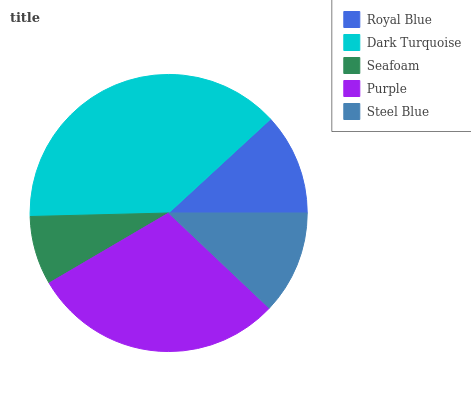Is Seafoam the minimum?
Answer yes or no. Yes. Is Dark Turquoise the maximum?
Answer yes or no. Yes. Is Dark Turquoise the minimum?
Answer yes or no. No. Is Seafoam the maximum?
Answer yes or no. No. Is Dark Turquoise greater than Seafoam?
Answer yes or no. Yes. Is Seafoam less than Dark Turquoise?
Answer yes or no. Yes. Is Seafoam greater than Dark Turquoise?
Answer yes or no. No. Is Dark Turquoise less than Seafoam?
Answer yes or no. No. Is Steel Blue the high median?
Answer yes or no. Yes. Is Steel Blue the low median?
Answer yes or no. Yes. Is Royal Blue the high median?
Answer yes or no. No. Is Dark Turquoise the low median?
Answer yes or no. No. 